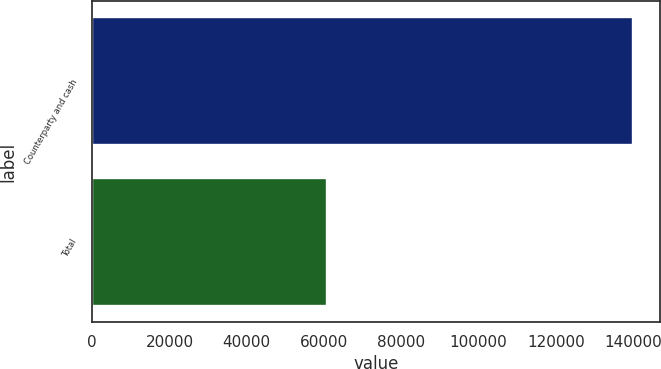<chart> <loc_0><loc_0><loc_500><loc_500><bar_chart><fcel>Counterparty and cash<fcel>Total<nl><fcel>139876<fcel>60737<nl></chart> 